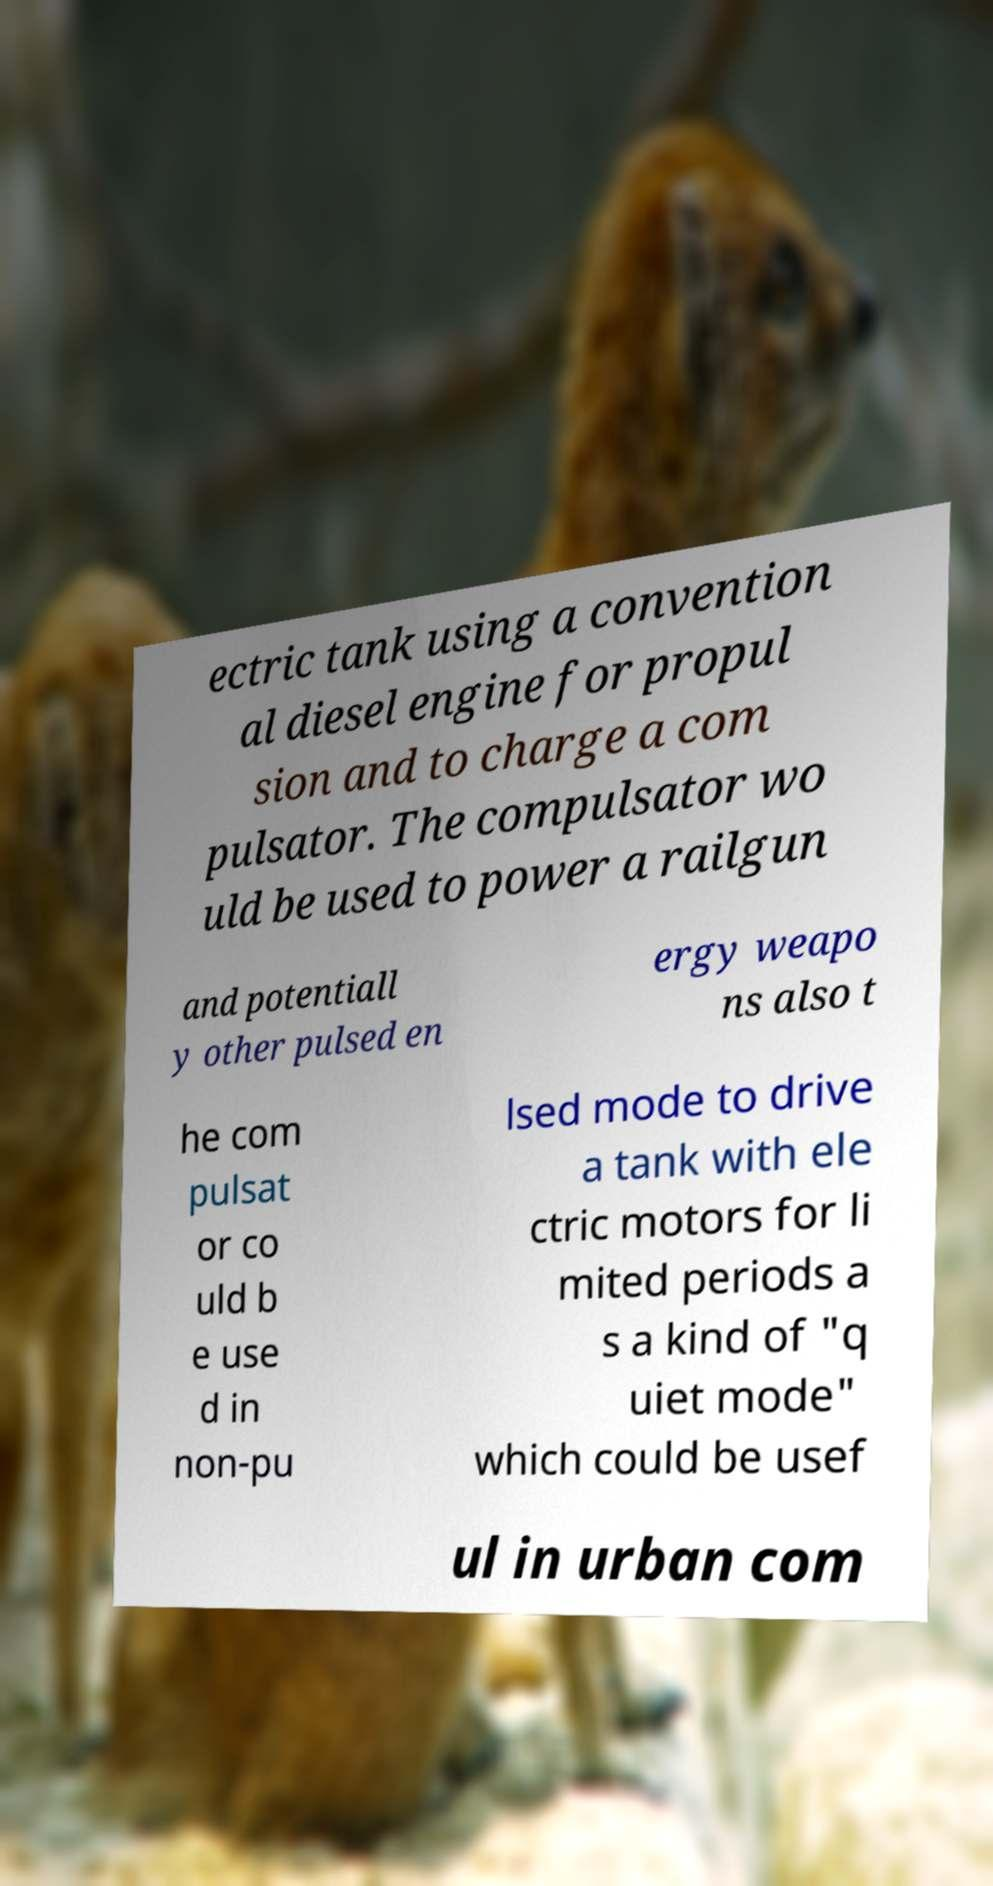There's text embedded in this image that I need extracted. Can you transcribe it verbatim? ectric tank using a convention al diesel engine for propul sion and to charge a com pulsator. The compulsator wo uld be used to power a railgun and potentiall y other pulsed en ergy weapo ns also t he com pulsat or co uld b e use d in non-pu lsed mode to drive a tank with ele ctric motors for li mited periods a s a kind of "q uiet mode" which could be usef ul in urban com 